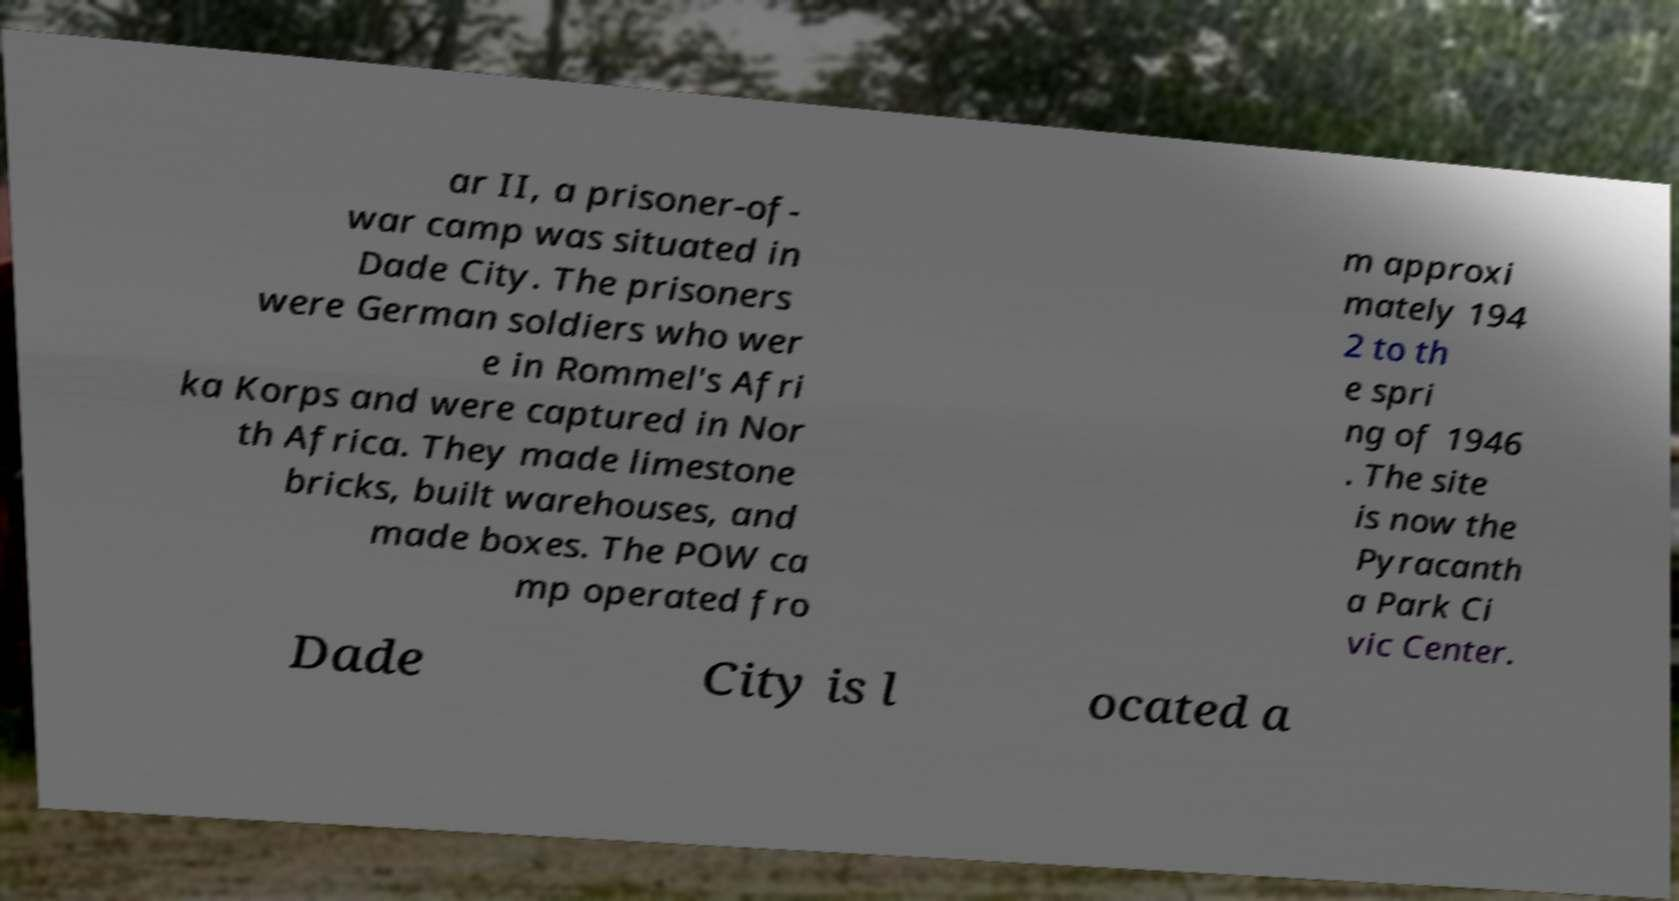There's text embedded in this image that I need extracted. Can you transcribe it verbatim? ar II, a prisoner-of- war camp was situated in Dade City. The prisoners were German soldiers who wer e in Rommel's Afri ka Korps and were captured in Nor th Africa. They made limestone bricks, built warehouses, and made boxes. The POW ca mp operated fro m approxi mately 194 2 to th e spri ng of 1946 . The site is now the Pyracanth a Park Ci vic Center. Dade City is l ocated a 